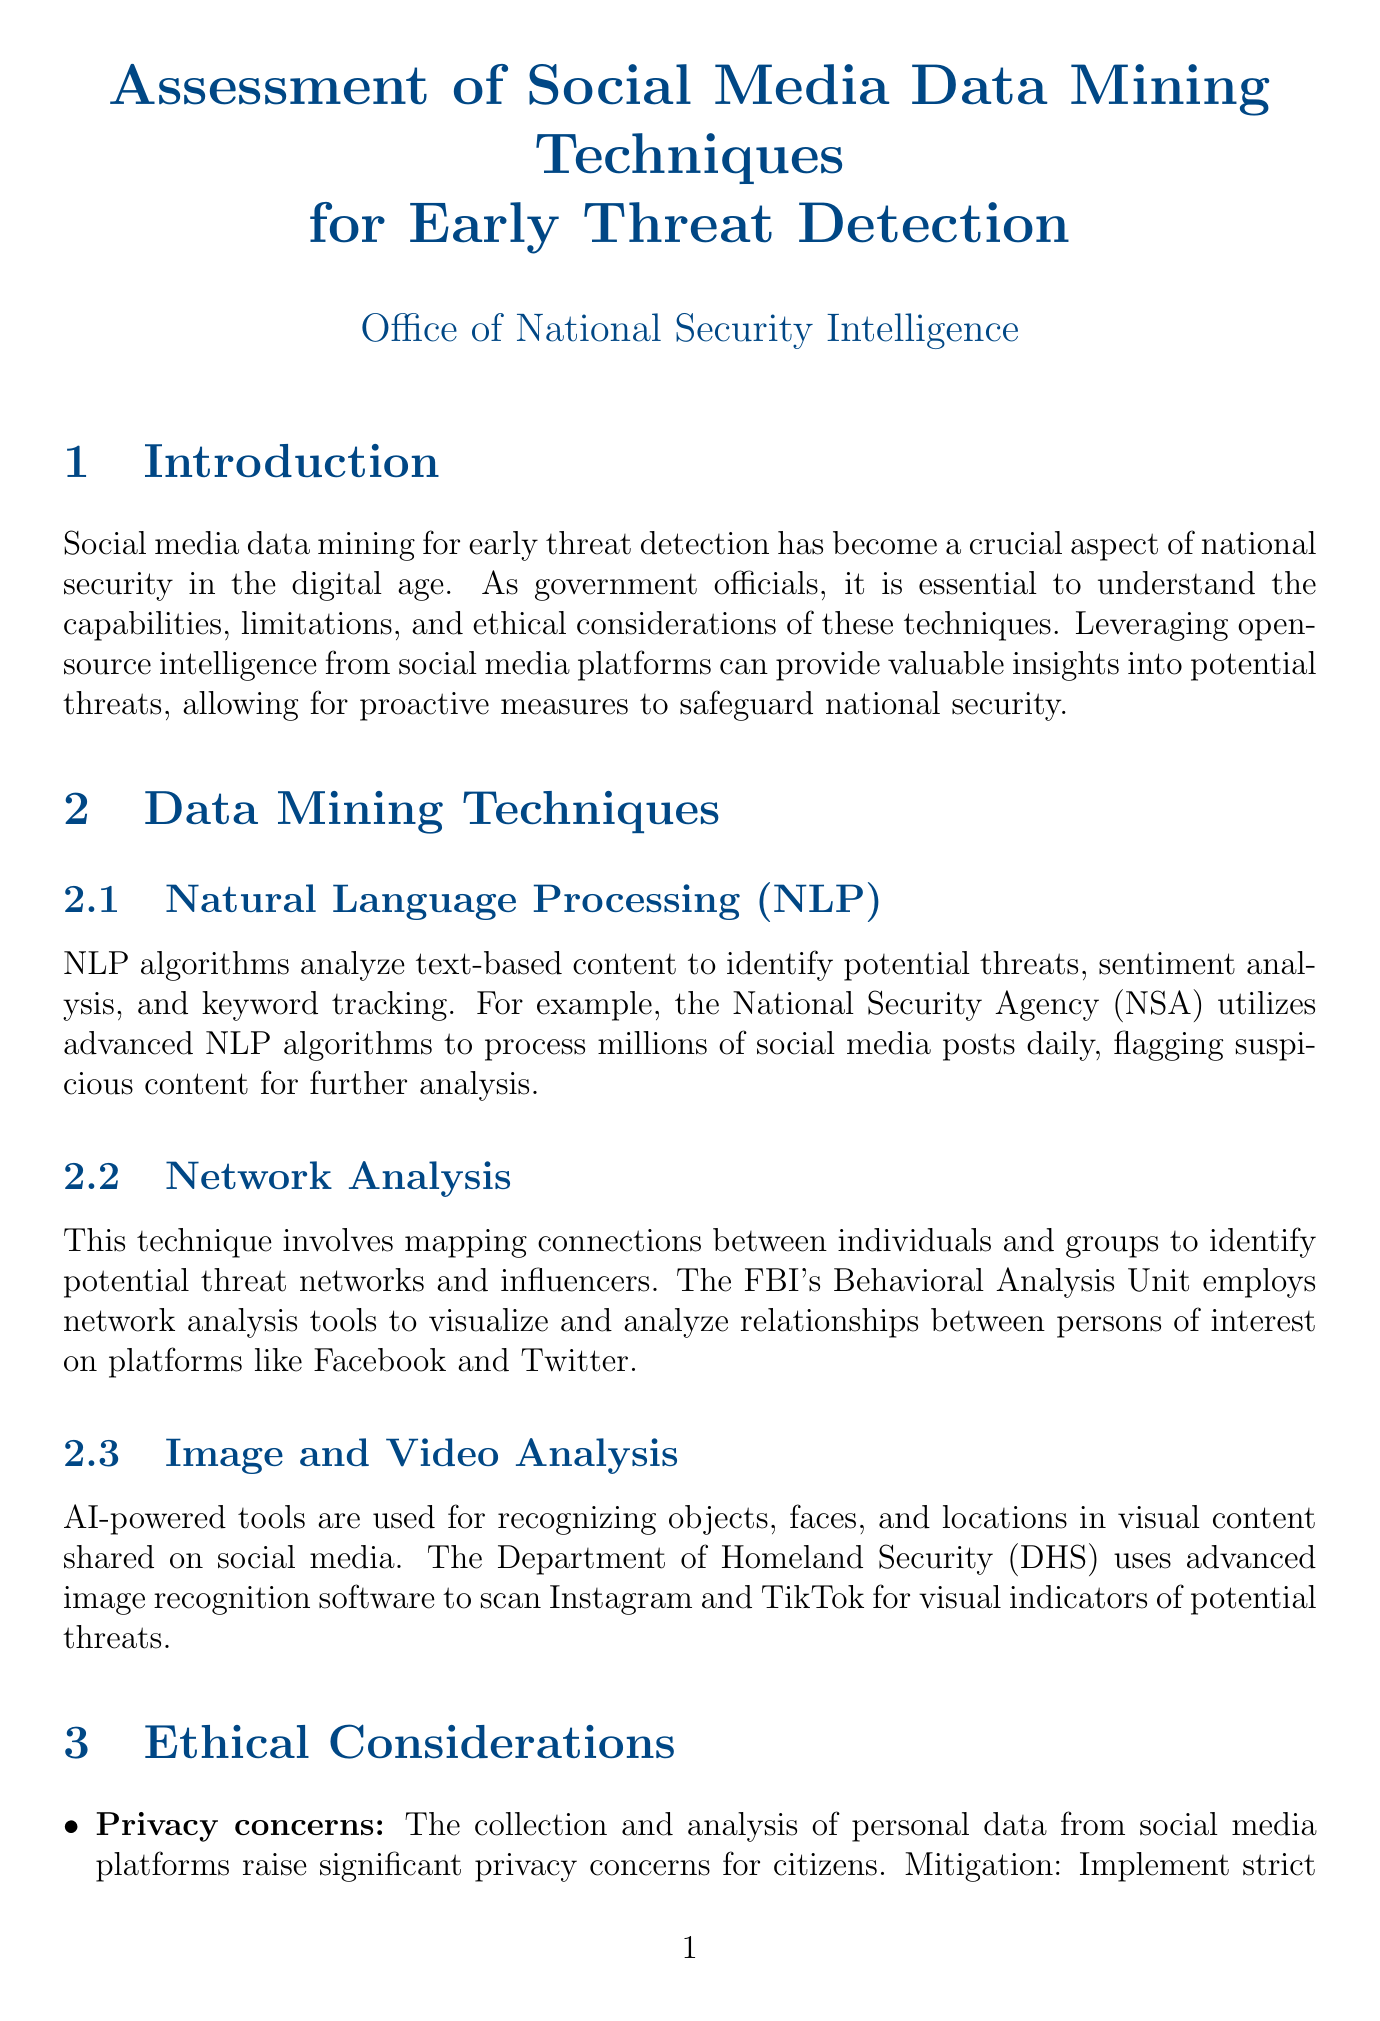What are the three data mining techniques mentioned? The document lists Natural Language Processing, Network Analysis, and Image and Video Analysis as the three data mining techniques.
Answer: Natural Language Processing, Network Analysis, Image and Video Analysis What is the ethical issue related to data mining regarding citizens? The ethical issue concerning data mining as it relates to citizens is privacy concerns, which are highlighted in the document.
Answer: Privacy concerns Which legal framework requires obtaining proper legal authorization for accessing non-public social media content? The Fourth Amendment requires proper legal authorization before accessing non-public social media content.
Answer: Fourth Amendment What successful operation involved a joint FBI-CIA initiative? The report mentions Operation CENTAUR as a successful operation involving a joint FBI-CIA initiative.
Answer: Operation CENTAUR What is one challenge related to the volume of social media data? The document states that the sheer amount of social media data generated daily poses significant processing challenges.
Answer: Data volume and velocity What technology trend could enable collaborative threat detection while preserving data privacy? Federated learning is mentioned as a trend that could enable collaborative threat detection while preserving data privacy.
Answer: Federated learning Which government agency utilizes advanced NLP algorithms according to the report? The National Security Agency (NSA) utilizes advanced NLP algorithms as per the document.
Answer: National Security Agency (NSA) What is a mitigation strategy for the bias in AI algorithms? The document suggests regularly auditing and refining algorithms to minimize bias as a mitigation strategy.
Answer: Regularly audit and refine algorithms 